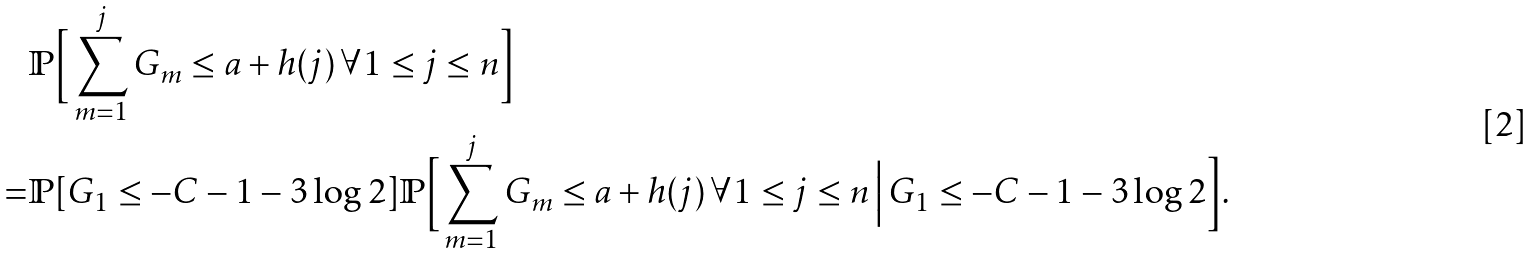Convert formula to latex. <formula><loc_0><loc_0><loc_500><loc_500>& \mathbb { P } \Big [ \sum _ { m = 1 } ^ { j } G _ { m } \leq a + h ( j ) \, \forall 1 \leq j \leq n \Big ] \\ = & \mathbb { P } [ G _ { 1 } \leq - C - 1 - 3 \log 2 ] \mathbb { P } \Big [ \sum _ { m = 1 } ^ { j } G _ { m } \leq a + h ( j ) \, \forall 1 \leq j \leq n \, \Big | \, G _ { 1 } \leq - C - 1 - 3 \log 2 \Big ] .</formula> 